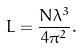<formula> <loc_0><loc_0><loc_500><loc_500>L = \frac { N \lambda ^ { 3 } } { 4 \pi ^ { 2 } } .</formula> 